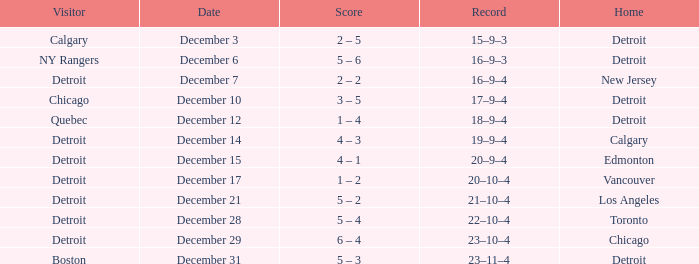Who is the visitor on december 3? Calgary. 